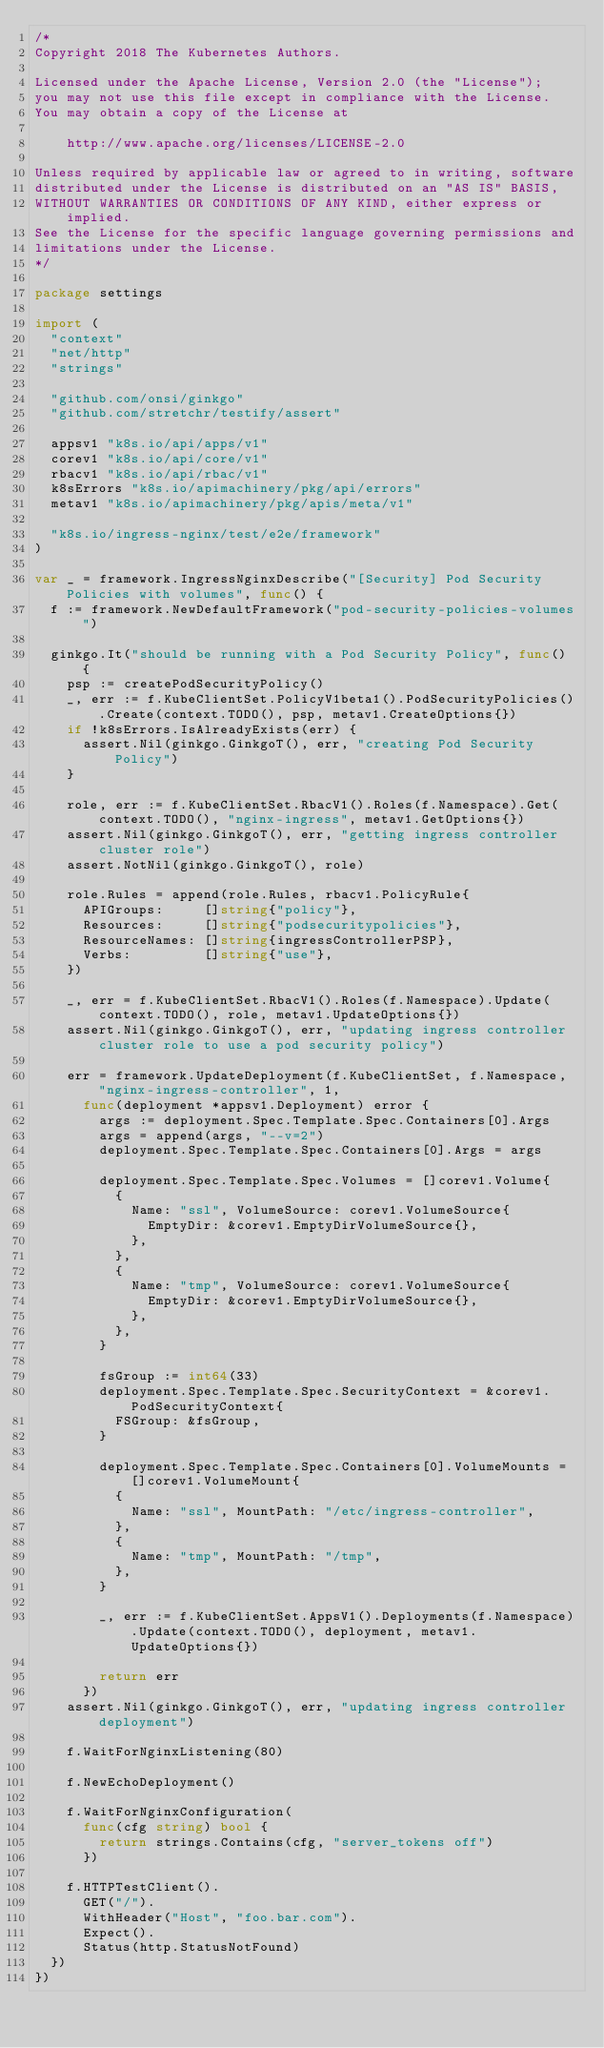Convert code to text. <code><loc_0><loc_0><loc_500><loc_500><_Go_>/*
Copyright 2018 The Kubernetes Authors.

Licensed under the Apache License, Version 2.0 (the "License");
you may not use this file except in compliance with the License.
You may obtain a copy of the License at

    http://www.apache.org/licenses/LICENSE-2.0

Unless required by applicable law or agreed to in writing, software
distributed under the License is distributed on an "AS IS" BASIS,
WITHOUT WARRANTIES OR CONDITIONS OF ANY KIND, either express or implied.
See the License for the specific language governing permissions and
limitations under the License.
*/

package settings

import (
	"context"
	"net/http"
	"strings"

	"github.com/onsi/ginkgo"
	"github.com/stretchr/testify/assert"

	appsv1 "k8s.io/api/apps/v1"
	corev1 "k8s.io/api/core/v1"
	rbacv1 "k8s.io/api/rbac/v1"
	k8sErrors "k8s.io/apimachinery/pkg/api/errors"
	metav1 "k8s.io/apimachinery/pkg/apis/meta/v1"

	"k8s.io/ingress-nginx/test/e2e/framework"
)

var _ = framework.IngressNginxDescribe("[Security] Pod Security Policies with volumes", func() {
	f := framework.NewDefaultFramework("pod-security-policies-volumes")

	ginkgo.It("should be running with a Pod Security Policy", func() {
		psp := createPodSecurityPolicy()
		_, err := f.KubeClientSet.PolicyV1beta1().PodSecurityPolicies().Create(context.TODO(), psp, metav1.CreateOptions{})
		if !k8sErrors.IsAlreadyExists(err) {
			assert.Nil(ginkgo.GinkgoT(), err, "creating Pod Security Policy")
		}

		role, err := f.KubeClientSet.RbacV1().Roles(f.Namespace).Get(context.TODO(), "nginx-ingress", metav1.GetOptions{})
		assert.Nil(ginkgo.GinkgoT(), err, "getting ingress controller cluster role")
		assert.NotNil(ginkgo.GinkgoT(), role)

		role.Rules = append(role.Rules, rbacv1.PolicyRule{
			APIGroups:     []string{"policy"},
			Resources:     []string{"podsecuritypolicies"},
			ResourceNames: []string{ingressControllerPSP},
			Verbs:         []string{"use"},
		})

		_, err = f.KubeClientSet.RbacV1().Roles(f.Namespace).Update(context.TODO(), role, metav1.UpdateOptions{})
		assert.Nil(ginkgo.GinkgoT(), err, "updating ingress controller cluster role to use a pod security policy")

		err = framework.UpdateDeployment(f.KubeClientSet, f.Namespace, "nginx-ingress-controller", 1,
			func(deployment *appsv1.Deployment) error {
				args := deployment.Spec.Template.Spec.Containers[0].Args
				args = append(args, "--v=2")
				deployment.Spec.Template.Spec.Containers[0].Args = args

				deployment.Spec.Template.Spec.Volumes = []corev1.Volume{
					{
						Name: "ssl", VolumeSource: corev1.VolumeSource{
							EmptyDir: &corev1.EmptyDirVolumeSource{},
						},
					},
					{
						Name: "tmp", VolumeSource: corev1.VolumeSource{
							EmptyDir: &corev1.EmptyDirVolumeSource{},
						},
					},
				}

				fsGroup := int64(33)
				deployment.Spec.Template.Spec.SecurityContext = &corev1.PodSecurityContext{
					FSGroup: &fsGroup,
				}

				deployment.Spec.Template.Spec.Containers[0].VolumeMounts = []corev1.VolumeMount{
					{
						Name: "ssl", MountPath: "/etc/ingress-controller",
					},
					{
						Name: "tmp", MountPath: "/tmp",
					},
				}

				_, err := f.KubeClientSet.AppsV1().Deployments(f.Namespace).Update(context.TODO(), deployment, metav1.UpdateOptions{})

				return err
			})
		assert.Nil(ginkgo.GinkgoT(), err, "updating ingress controller deployment")

		f.WaitForNginxListening(80)

		f.NewEchoDeployment()

		f.WaitForNginxConfiguration(
			func(cfg string) bool {
				return strings.Contains(cfg, "server_tokens off")
			})

		f.HTTPTestClient().
			GET("/").
			WithHeader("Host", "foo.bar.com").
			Expect().
			Status(http.StatusNotFound)
	})
})
</code> 